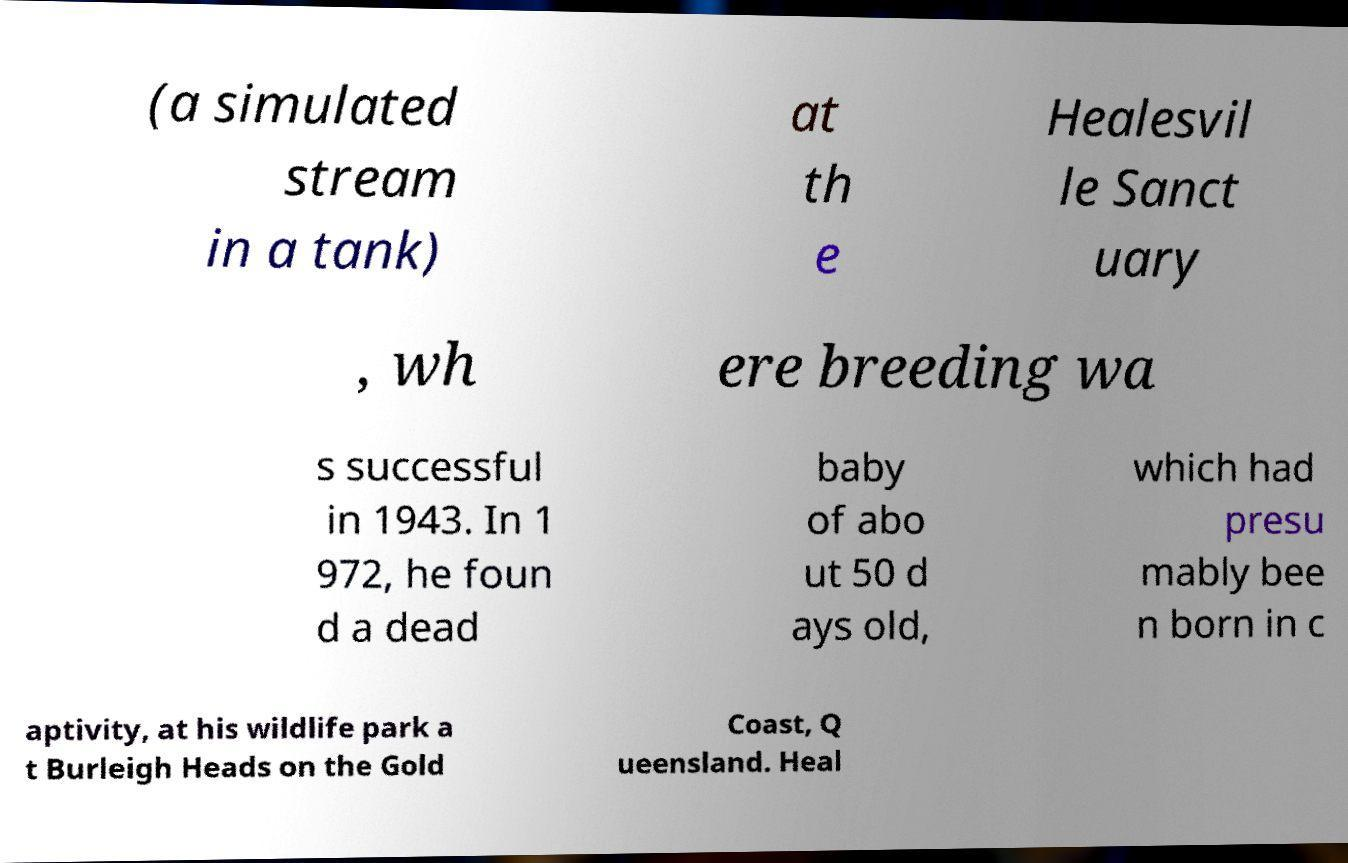Please identify and transcribe the text found in this image. (a simulated stream in a tank) at th e Healesvil le Sanct uary , wh ere breeding wa s successful in 1943. In 1 972, he foun d a dead baby of abo ut 50 d ays old, which had presu mably bee n born in c aptivity, at his wildlife park a t Burleigh Heads on the Gold Coast, Q ueensland. Heal 